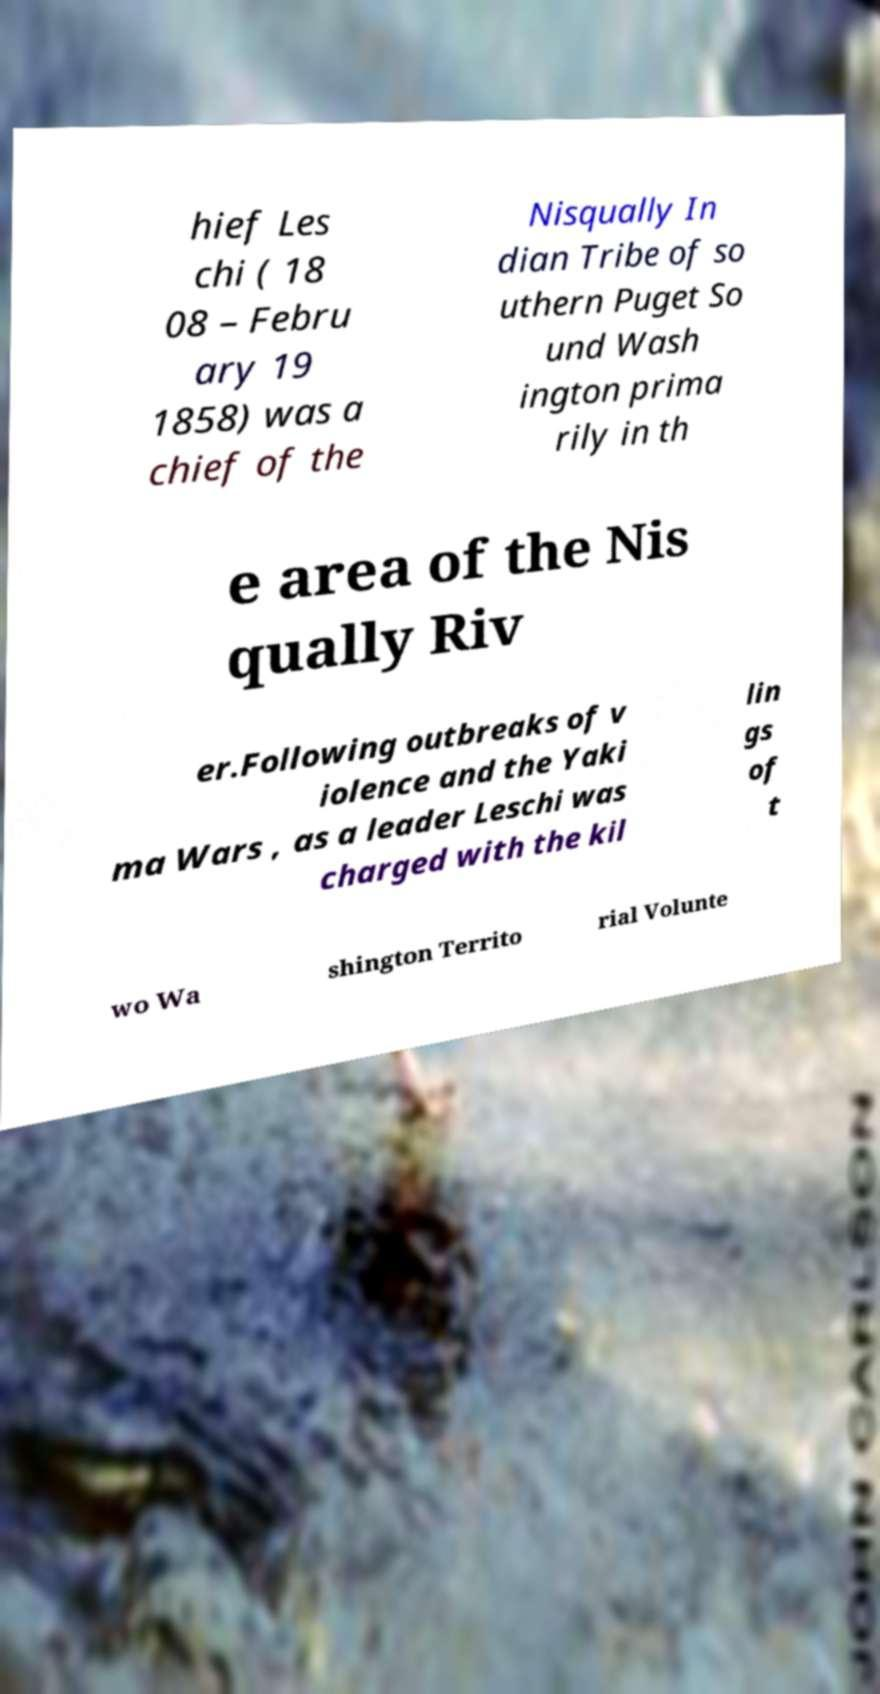For documentation purposes, I need the text within this image transcribed. Could you provide that? hief Les chi ( 18 08 – Febru ary 19 1858) was a chief of the Nisqually In dian Tribe of so uthern Puget So und Wash ington prima rily in th e area of the Nis qually Riv er.Following outbreaks of v iolence and the Yaki ma Wars , as a leader Leschi was charged with the kil lin gs of t wo Wa shington Territo rial Volunte 